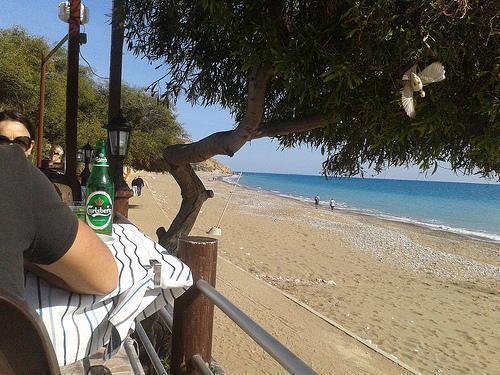How many people are walking by the water's edge?
Give a very brief answer. 2. 